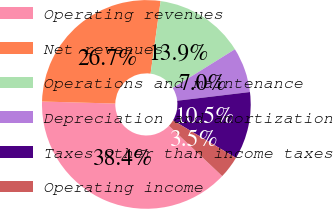Convert chart. <chart><loc_0><loc_0><loc_500><loc_500><pie_chart><fcel>Operating revenues<fcel>Net revenues<fcel>Operations and maintenance<fcel>Depreciation and amortization<fcel>Taxes other than income taxes<fcel>Operating income<nl><fcel>38.4%<fcel>26.74%<fcel>13.95%<fcel>6.97%<fcel>10.46%<fcel>3.48%<nl></chart> 